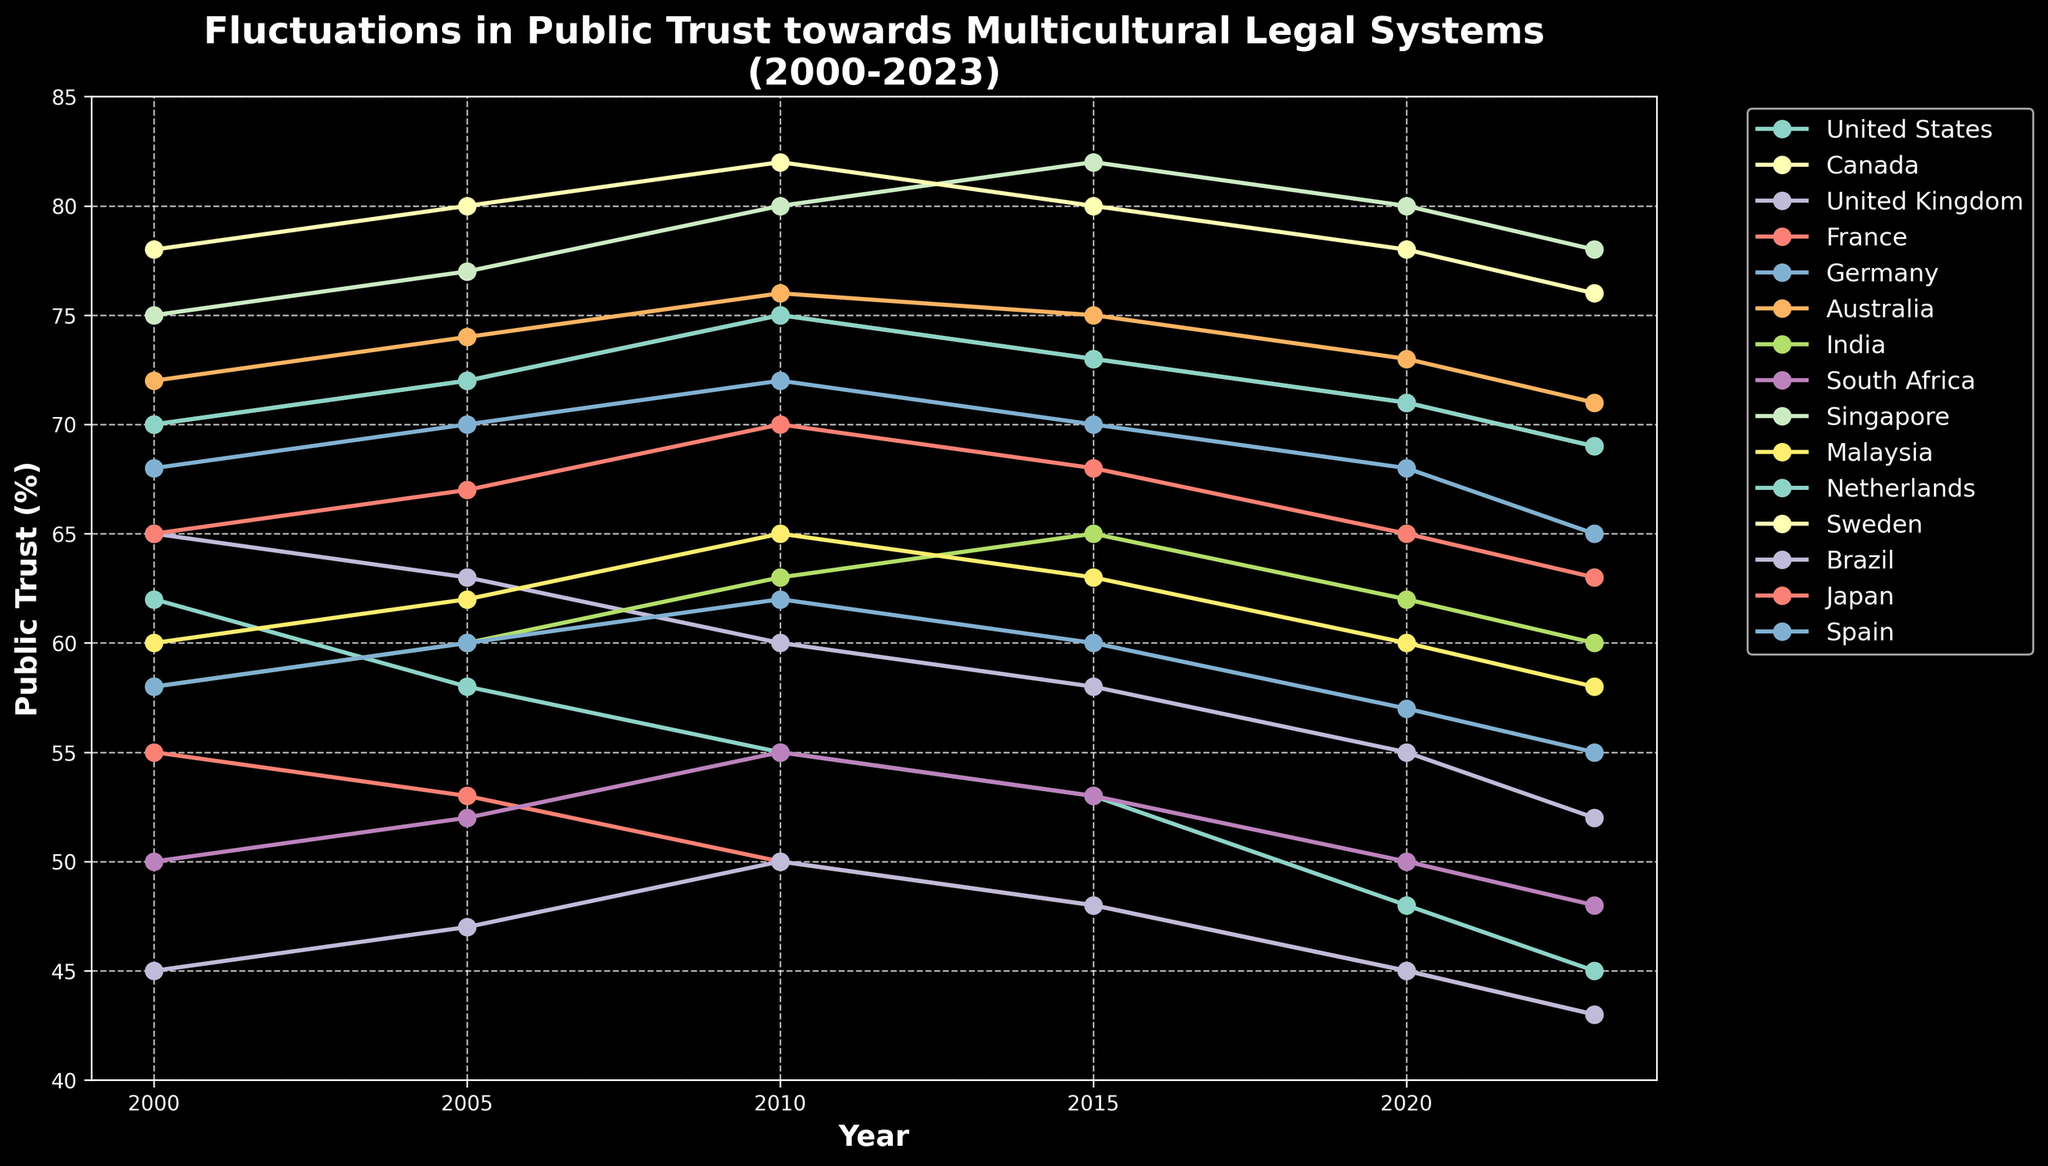Which country had the highest public trust in 2023? Observe the y-values for all countries in 2023 and compare them. Singapore had the highest with 78%.
Answer: Singapore Between 2000 and 2023, which country experienced the largest drop in public trust? Calculate the difference in public trust between 2000 and 2023 for each country, then identify the largest drop. United States dropped from 62% to 45%, which is a 17% decrease.
Answer: United States How did public trust in multicultural legal systems in Germany fluctuate between 2000 and 2023? Plot the points for Germany over the years and describe the trend. Trust rose from 68% in 2000 to 72% in 2010, then gradually declined to 65% by 2023.
Answer: Initially increased then decreased Which two countries had equal public trust in both 2005 and 2020? Compare public trust values across countries for 2005 and 2020 and identify matches. Canada and Netherlands both had 72% in 2005 and 71% in 2020.
Answer: Canada and Netherlands What is the average public trust in multicultural legal systems in Malaysia from 2000 to 2023? Sum the public trust values for Malaysia across the years and divide by the number of data points. (60 + 62 + 65 + 63 + 60 + 58) / 6 = 61.3%
Answer: 61.3% Which country showed consistent growth in public trust until 2015 and then declined? Identify the countries with an increasing trend until 2015 and observe if there is a drop post-2015. India had growth until 2015 (58% to 65%) and declined after (62% in 2020, 60% in 2023).
Answer: India Between the United Kingdom and France, which country had a greater decline in public trust between 2000 and 2023? Calculate the trust percentage drop for both. UK declined from 65% to 52% (13%), France declined from 55% to 43% (12%).
Answer: United Kingdom What is the trend in public trust in South Africa’s multicultural legal systems from 2000 to 2023? Describe the trajectory based on the plotted values. South Africa's trust increased slightly from 2000 (50%) to 2010 (55%), then gradually decreased to 48% by 2023.
Answer: Slight increase then decrease 